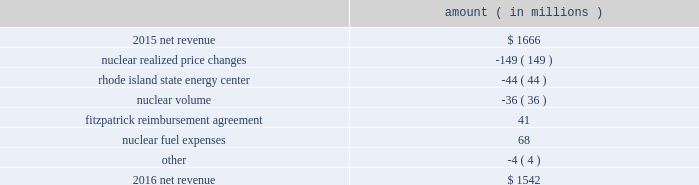Entergy corporation and subsidiaries management 2019s financial discussion and analysis combination .
Consistent with the terms of the stipulated settlement in the business combination proceeding , electric customers of entergy louisiana will realize customer credits associated with the business combination ; accordingly , in october 2015 , entergy recorded a regulatory liability of $ 107 million ( $ 66 million net-of-tax ) .
These costs are being amortized over a nine-year period beginning december 2015 .
See note 2 to the financial statements for further discussion of the business combination and customer credits .
The volume/weather variance is primarily due to the effect of more favorable weather during the unbilled period and an increase in industrial usage , partially offset by the effect of less favorable weather on residential sales .
The increase in industrial usage is primarily due to expansion projects , primarily in the chemicals industry , and increased demand from new customers , primarily in the industrial gases industry .
The louisiana act 55 financing savings obligation variance results from a regulatory charge for tax savings to be shared with customers per an agreement approved by the lpsc .
The tax savings results from the 2010-2011 irs audit settlement on the treatment of the louisiana act 55 financing of storm costs for hurricane gustav and hurricane ike .
See note 3 to the financial statements for additional discussion of the settlement and benefit sharing .
Included in other is a provision of $ 23 million recorded in 2016 related to the settlement of the waterford 3 replacement steam generator prudence review proceeding , offset by a provision of $ 32 million recorded in 2015 related to the uncertainty at that time associated with the resolution of the waterford 3 replacement steam generator prudence review proceeding .
See note 2 to the financial statements for a discussion of the waterford 3 replacement steam generator prudence review proceeding .
Entergy wholesale commodities following is an analysis of the change in net revenue comparing 2016 to 2015 .
Amount ( in millions ) .
As shown in the table above , net revenue for entergy wholesale commodities decreased by approximately $ 124 million in 2016 primarily due to : 2022 lower realized wholesale energy prices and lower capacity prices , although the average revenue per mwh shown in the table below for the nuclear fleet is slightly higher because it includes revenues from the fitzpatrick reimbursement agreement with exelon , the amortization of the palisades below-market ppa , and vermont yankee capacity revenue .
The effect of the amortization of the palisades below-market ppa and vermont yankee capacity revenue on the net revenue variance from 2015 to 2016 is minimal ; 2022 the sale of the rhode island state energy center in december 2015 .
See note 14 to the financial statements for further discussion of the rhode island state energy center sale ; and 2022 lower volume in the entergy wholesale commodities nuclear fleet resulting from more refueling outage days in 2016 as compared to 2015 and larger exercise of resupply options in 2016 as compared to 2015 .
See 201cnuclear .
What is the net change in net revenue during 2016? 
Computations: (1542 - 1666)
Answer: -124.0. 